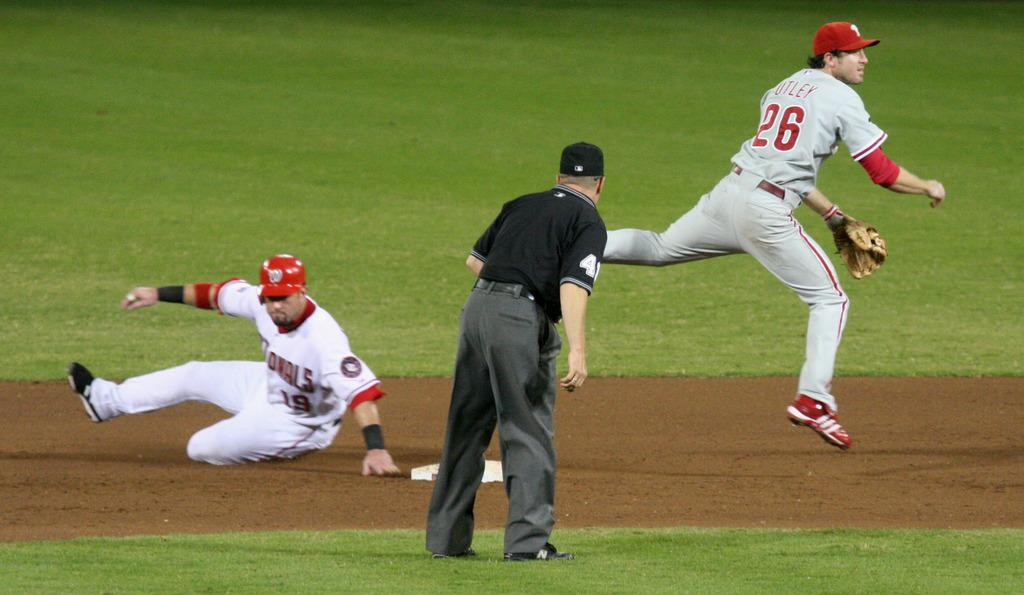How many people are in the image? There are three persons in the image. What is the position of the persons in the image? The persons are on the ground. What type of surface can be seen in the image? There is grass on the surface in the image. What type of celery is being used as a prop in the image? There is no celery present in the image. What type of engine can be seen powering the action in the image? There is no engine or action present in the image; it features three persons on the ground with grass. 